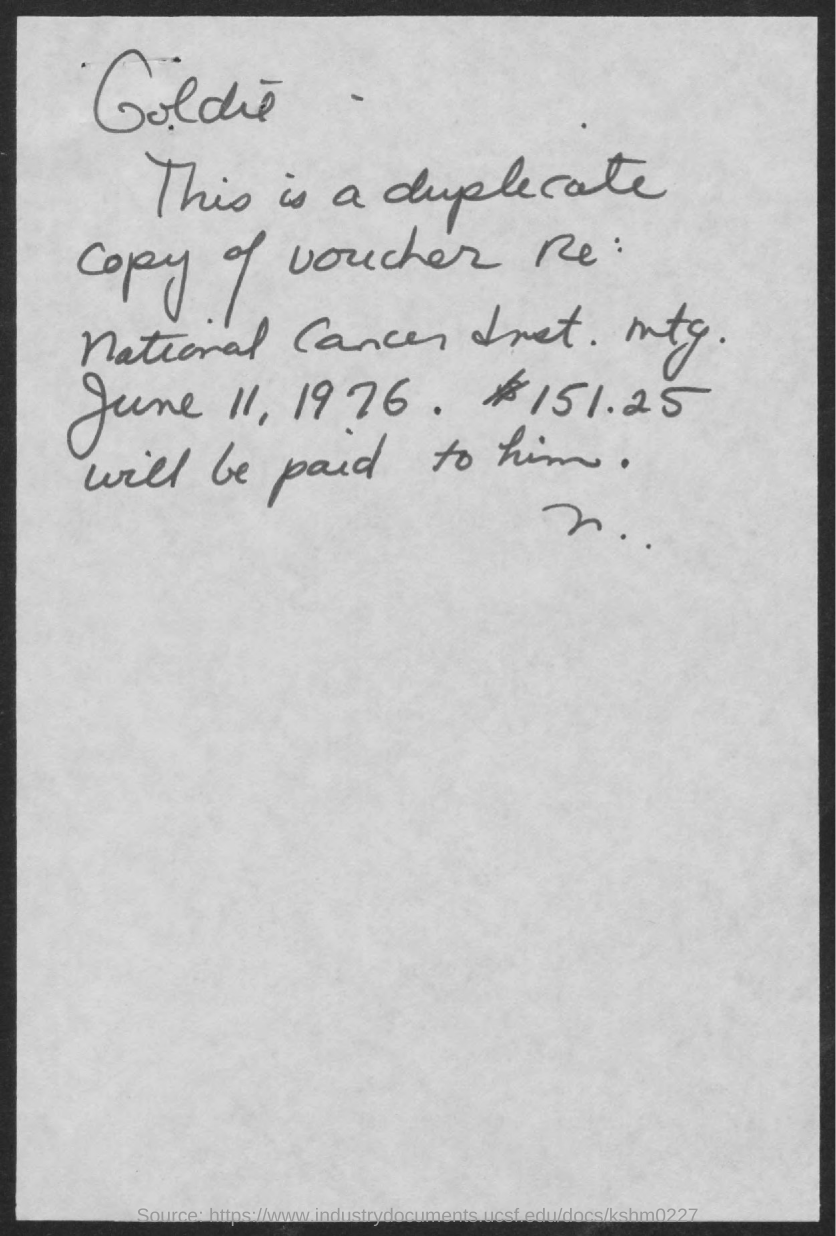What is the date mentioned in the given page ?
Your answer should be very brief. June 11, 1976. What is the amount mentioned in the given form ?
Your answer should be very brief. 151.25. 